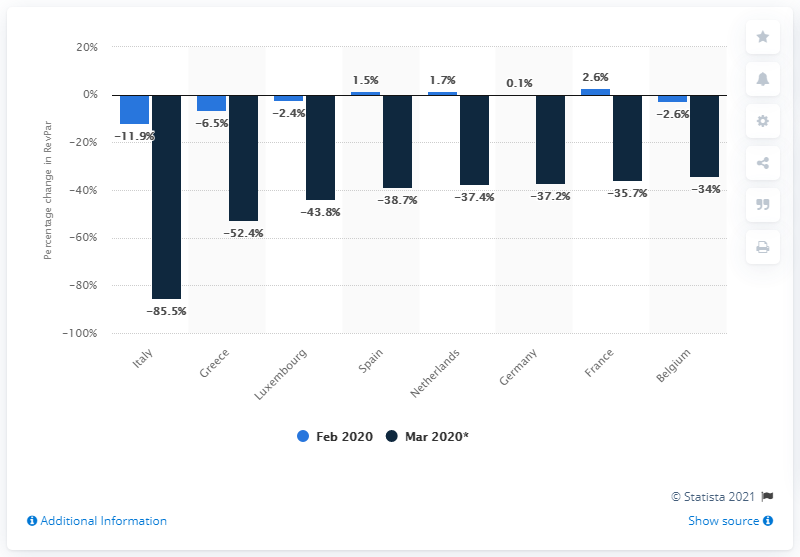Draw attention to some important aspects in this diagram. The number of cases of coronavirus has rapidly increased in Italy. 